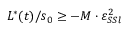Convert formula to latex. <formula><loc_0><loc_0><loc_500><loc_500>L ^ { * } ( t ) / s _ { 0 } \geq - M \cdot \varepsilon _ { S S l } ^ { 2 }</formula> 